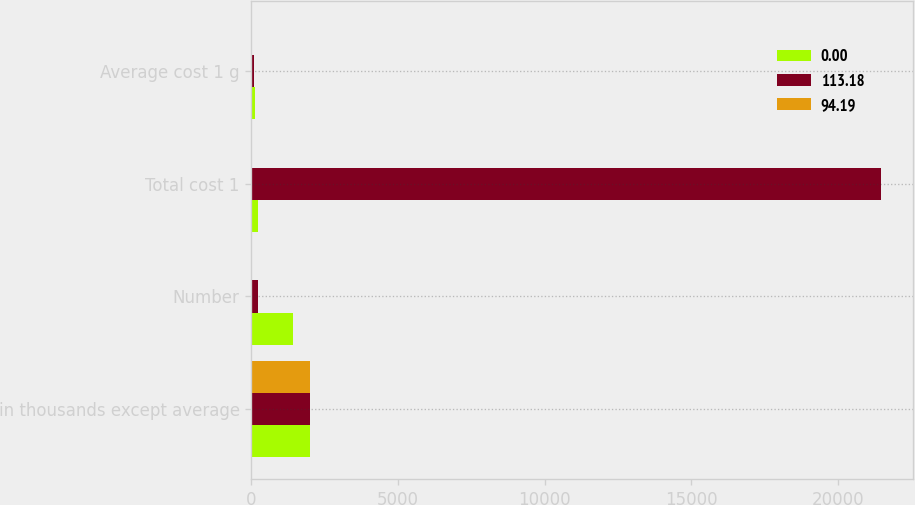<chart> <loc_0><loc_0><loc_500><loc_500><stacked_bar_chart><ecel><fcel>in thousands except average<fcel>Number<fcel>Total cost 1<fcel>Average cost 1 g<nl><fcel>0<fcel>2016<fcel>1427<fcel>228<fcel>113.18<nl><fcel>113.18<fcel>2015<fcel>228<fcel>21475<fcel>94.19<nl><fcel>94.19<fcel>2014<fcel>0<fcel>0<fcel>0<nl></chart> 